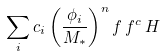Convert formula to latex. <formula><loc_0><loc_0><loc_500><loc_500>\sum _ { i } c _ { i } \left ( \frac { \phi _ { i } } { M _ { * } } \right ) ^ { n } f \, f ^ { c } \, H</formula> 